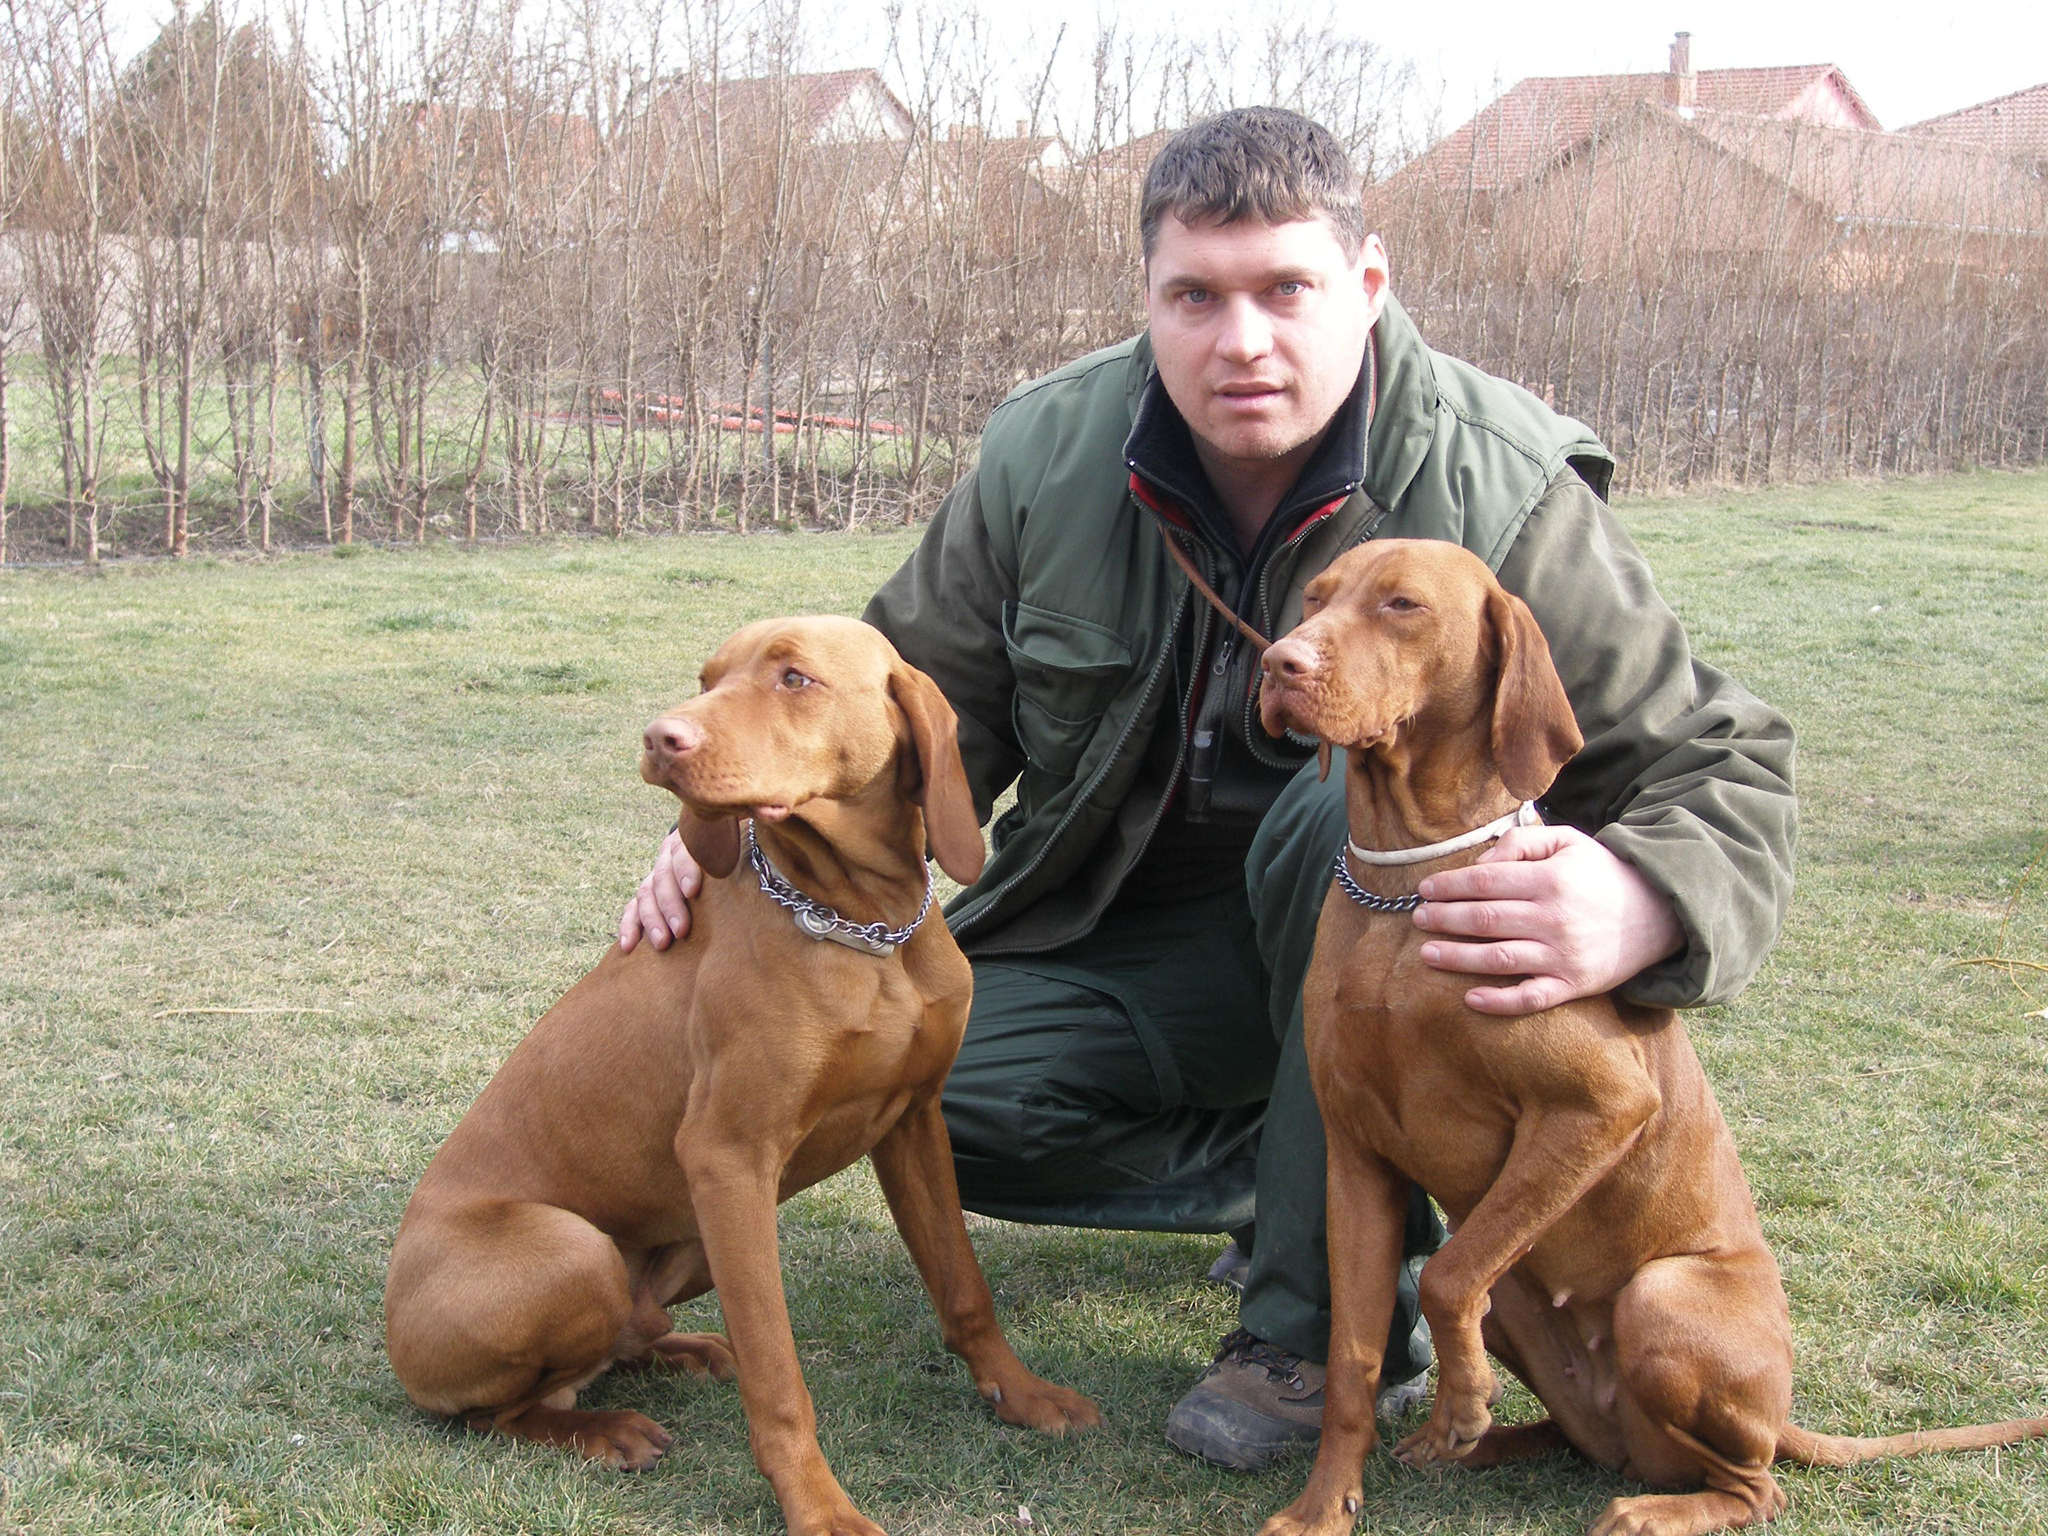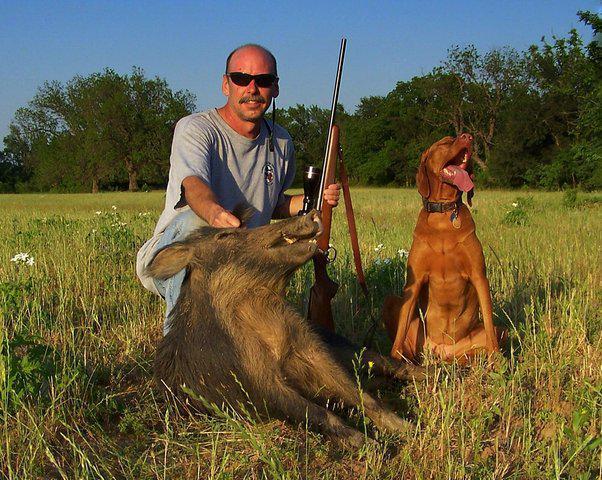The first image is the image on the left, the second image is the image on the right. For the images shown, is this caption "One dog is wearing an item on it's back and the rest are only wearing collars." true? Answer yes or no. No. The first image is the image on the left, the second image is the image on the right. Considering the images on both sides, is "There are three dogs sitting." valid? Answer yes or no. Yes. 